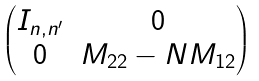Convert formula to latex. <formula><loc_0><loc_0><loc_500><loc_500>\begin{pmatrix} I _ { n , n ^ { \prime } } & 0 \\ 0 & M _ { 2 2 } - N M _ { 1 2 } \end{pmatrix}</formula> 